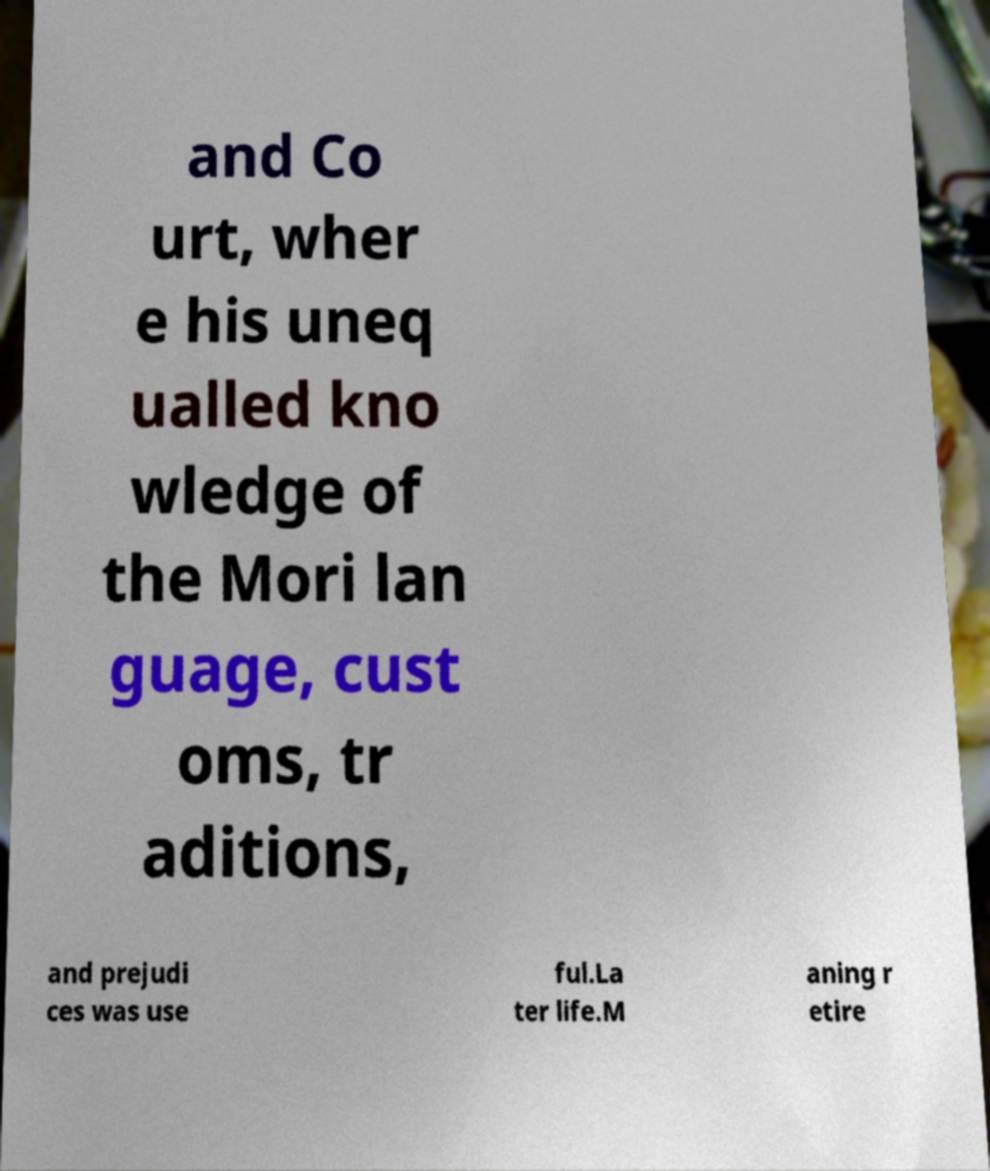Please identify and transcribe the text found in this image. and Co urt, wher e his uneq ualled kno wledge of the Mori lan guage, cust oms, tr aditions, and prejudi ces was use ful.La ter life.M aning r etire 